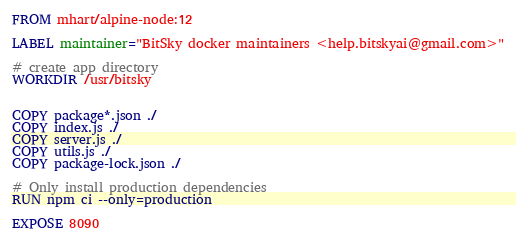<code> <loc_0><loc_0><loc_500><loc_500><_Dockerfile_>FROM mhart/alpine-node:12

LABEL maintainer="BitSky docker maintainers <help.bitskyai@gmail.com>"

# create app directory
WORKDIR /usr/bitsky


COPY package*.json ./
COPY index.js ./
COPY server.js ./
COPY utils.js ./
COPY package-lock.json ./

# Only install production dependencies
RUN npm ci --only=production

EXPOSE 8090</code> 